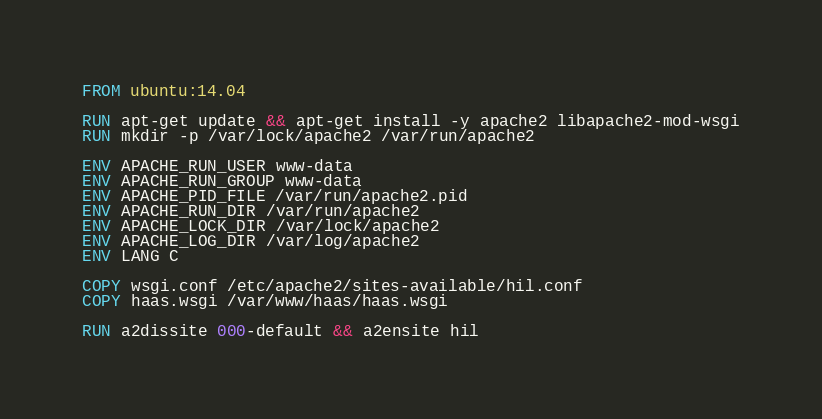<code> <loc_0><loc_0><loc_500><loc_500><_Dockerfile_>FROM ubuntu:14.04

RUN apt-get update && apt-get install -y apache2 libapache2-mod-wsgi
RUN mkdir -p /var/lock/apache2 /var/run/apache2

ENV APACHE_RUN_USER www-data
ENV APACHE_RUN_GROUP www-data
ENV APACHE_PID_FILE /var/run/apache2.pid
ENV APACHE_RUN_DIR /var/run/apache2
ENV APACHE_LOCK_DIR /var/lock/apache2
ENV APACHE_LOG_DIR /var/log/apache2
ENV LANG C

COPY wsgi.conf /etc/apache2/sites-available/hil.conf
COPY haas.wsgi /var/www/haas/haas.wsgi

RUN a2dissite 000-default && a2ensite hil
</code> 